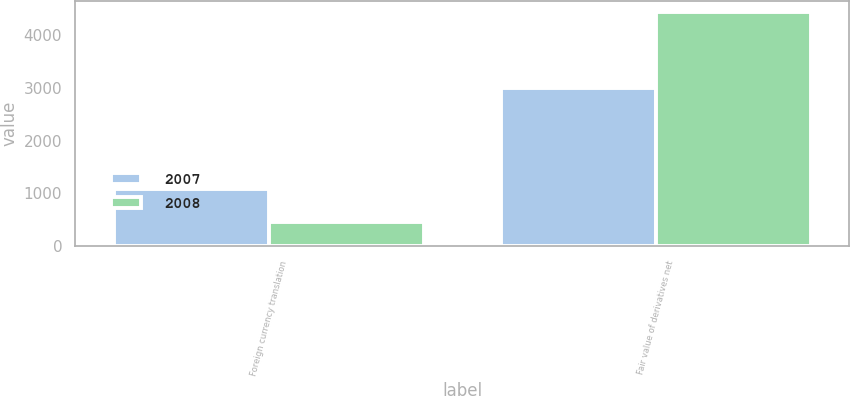<chart> <loc_0><loc_0><loc_500><loc_500><stacked_bar_chart><ecel><fcel>Foreign currency translation<fcel>Fair value of derivatives net<nl><fcel>2007<fcel>1091<fcel>3008<nl><fcel>2008<fcel>451<fcel>4432<nl></chart> 